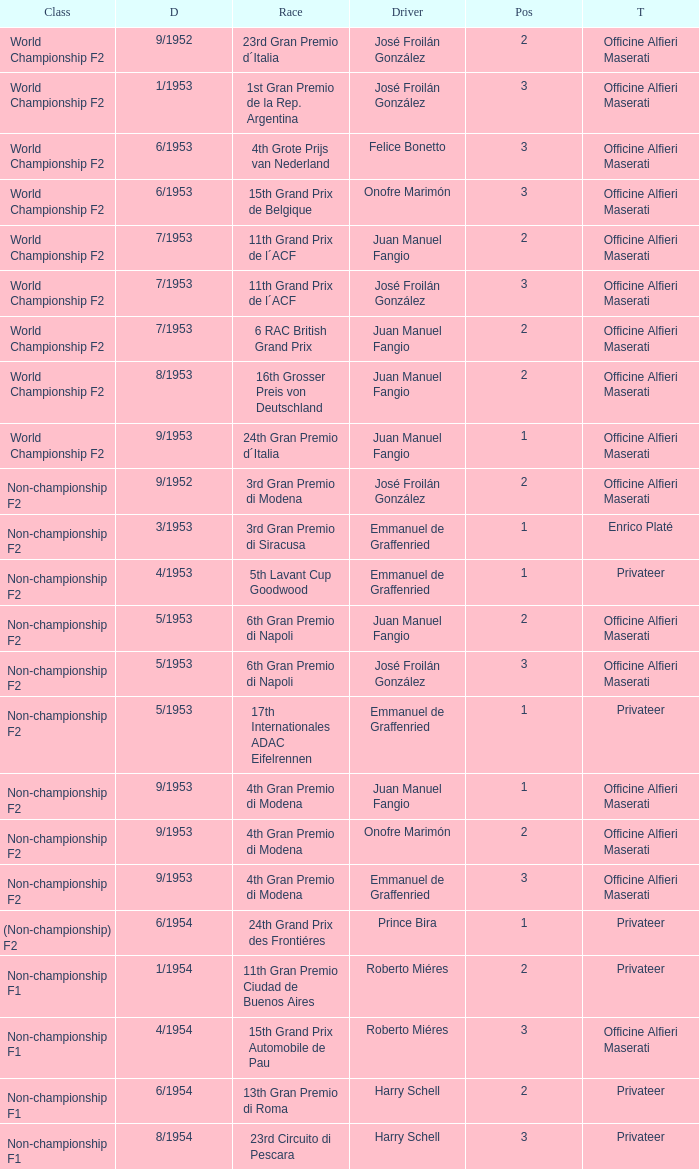What date has the class of non-championship f2 as well as a driver name josé froilán gonzález that has a position larger than 2? 5/1953. 